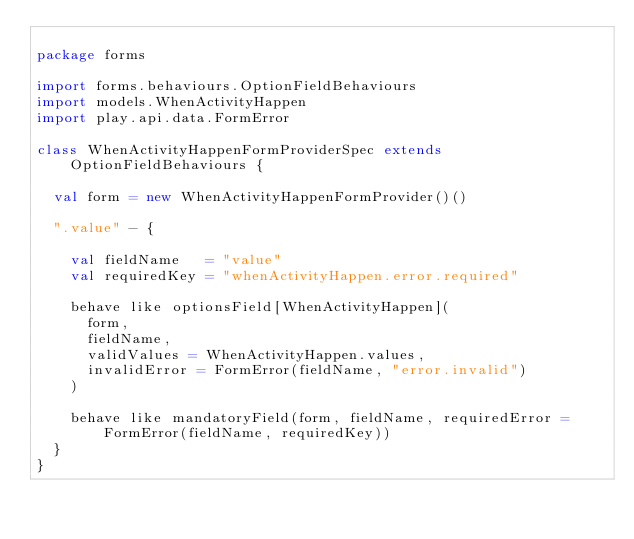<code> <loc_0><loc_0><loc_500><loc_500><_Scala_>
package forms

import forms.behaviours.OptionFieldBehaviours
import models.WhenActivityHappen
import play.api.data.FormError

class WhenActivityHappenFormProviderSpec extends OptionFieldBehaviours {

  val form = new WhenActivityHappenFormProvider()()

  ".value" - {

    val fieldName   = "value"
    val requiredKey = "whenActivityHappen.error.required"

    behave like optionsField[WhenActivityHappen](
      form,
      fieldName,
      validValues = WhenActivityHappen.values,
      invalidError = FormError(fieldName, "error.invalid")
    )

    behave like mandatoryField(form, fieldName, requiredError = FormError(fieldName, requiredKey))
  }
}
</code> 